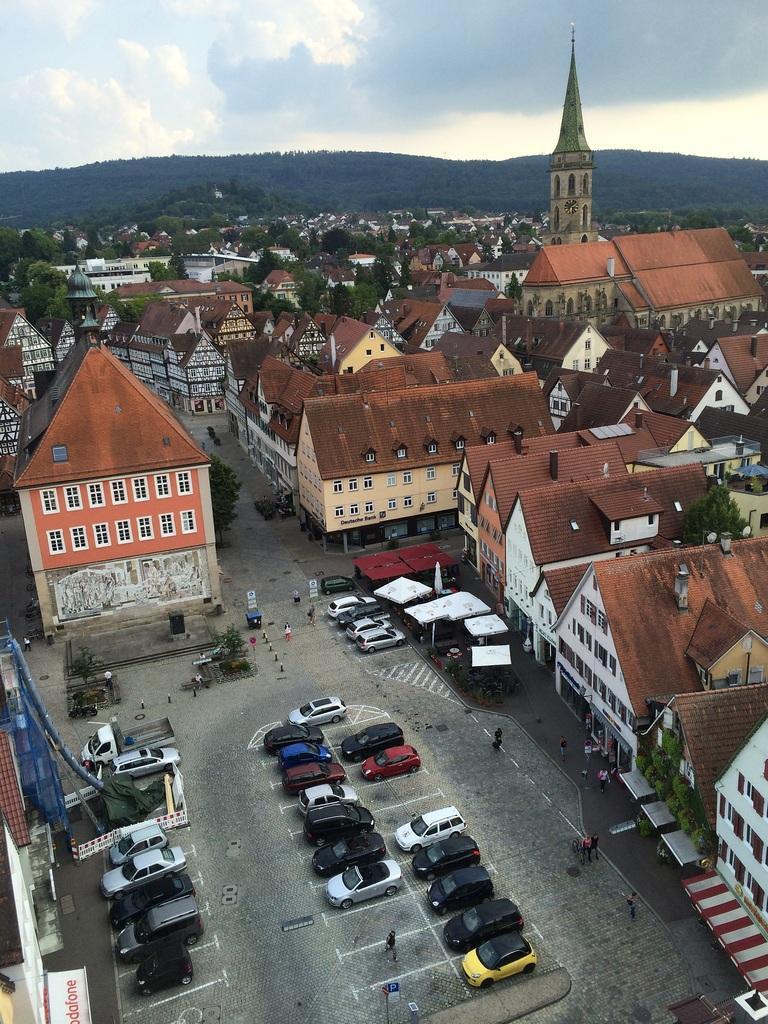Please provide a concise description of this image. This is a picture of city. In this picture there are cars, roads, buildings, trees, tents and table. In the background there are hills. Sky is cloudy. 